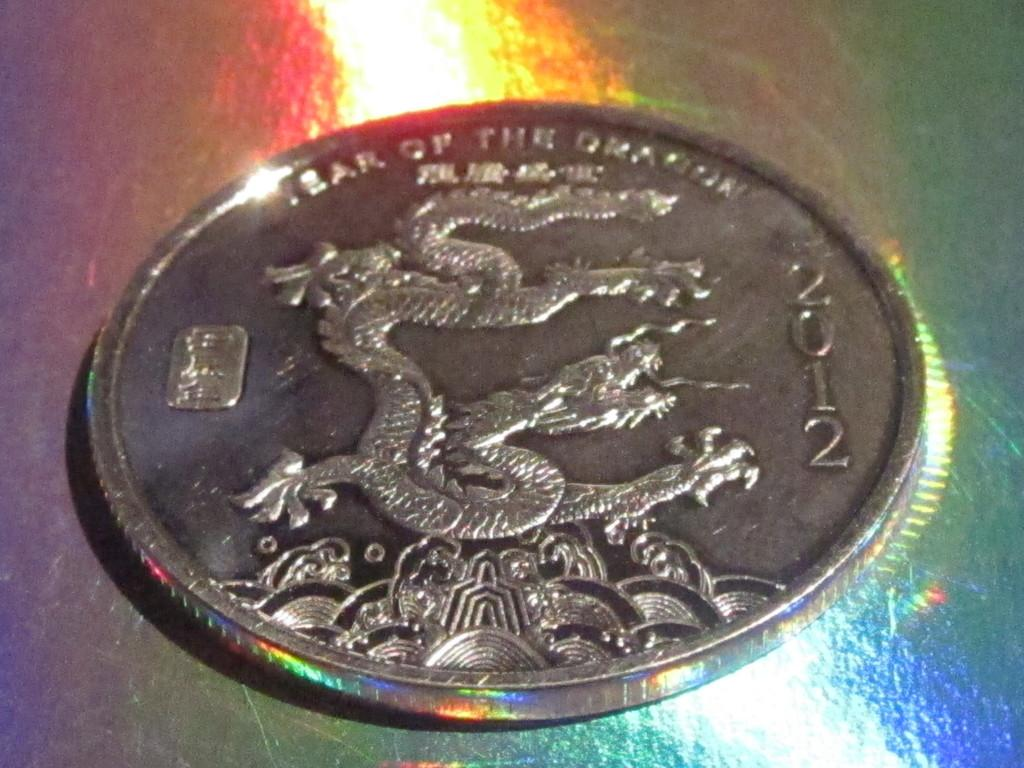<image>
Present a compact description of the photo's key features. A coin with a dragon on it was minted in 2012. 